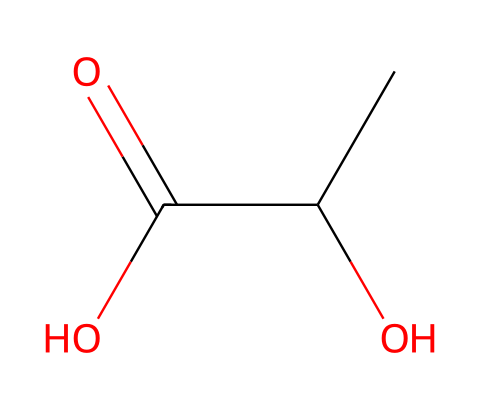What is the molecular formula of this compound? The SMILES representation "CC(O)C(=O)O" indicates that there are 3 carbon (C) atoms, 6 hydrogen (H) atoms, and 3 oxygen (O) atoms present in the structure. Hence, the molecular formula can be derived as C3H6O3.
Answer: C3H6O3 How many chiral centers are present in lactic acid? By examining the structure from the SMILES, we see that the carbon atom attached to the hydroxyl group (O) and the carboxylic group (C(=O)O) is a chiral center, as it has four different substituents. Thus, lactic acid has one chiral center.
Answer: 1 What type of functional groups are present in lactic acid? The chemical structure shows the presence of a hydroxyl group (-OH) and a carboxylic acid group (-COOH), which are identified as the functional groups in this molecule. Thus, lactic acid contains both of these groups.
Answer: hydroxyl and carboxylic acid What is the significance of lactic acid in cycling? Lactic acid is produced during anaerobic respiration when exercising intensely, such as in cycling. Its accumulation is associated with muscle fatigue, making it significant for cyclists. Therefore, lactic acid is crucial in understanding performance and endurance in cycling.
Answer: muscle fatigue What is the pH of lactic acid in solution? Lactic acid is a weak acid, and typically, a 1 M solution has a pH value around 3.86, making it acidic. The concentration slightly influences its pH in various conditions but generally falls within this range.
Answer: 3.86 How many hydrogen atoms are bonded to the central carbon in lactic acid? The central carbon atom in lactic acid is part of the structure showing a hydroxyl group (-OH) and a carboxyl group. The central carbon is bonded to one hydrogen atom along with carbon chains and functional groups, which results in a total of one hydrogen atom being directly bonded.
Answer: 1 